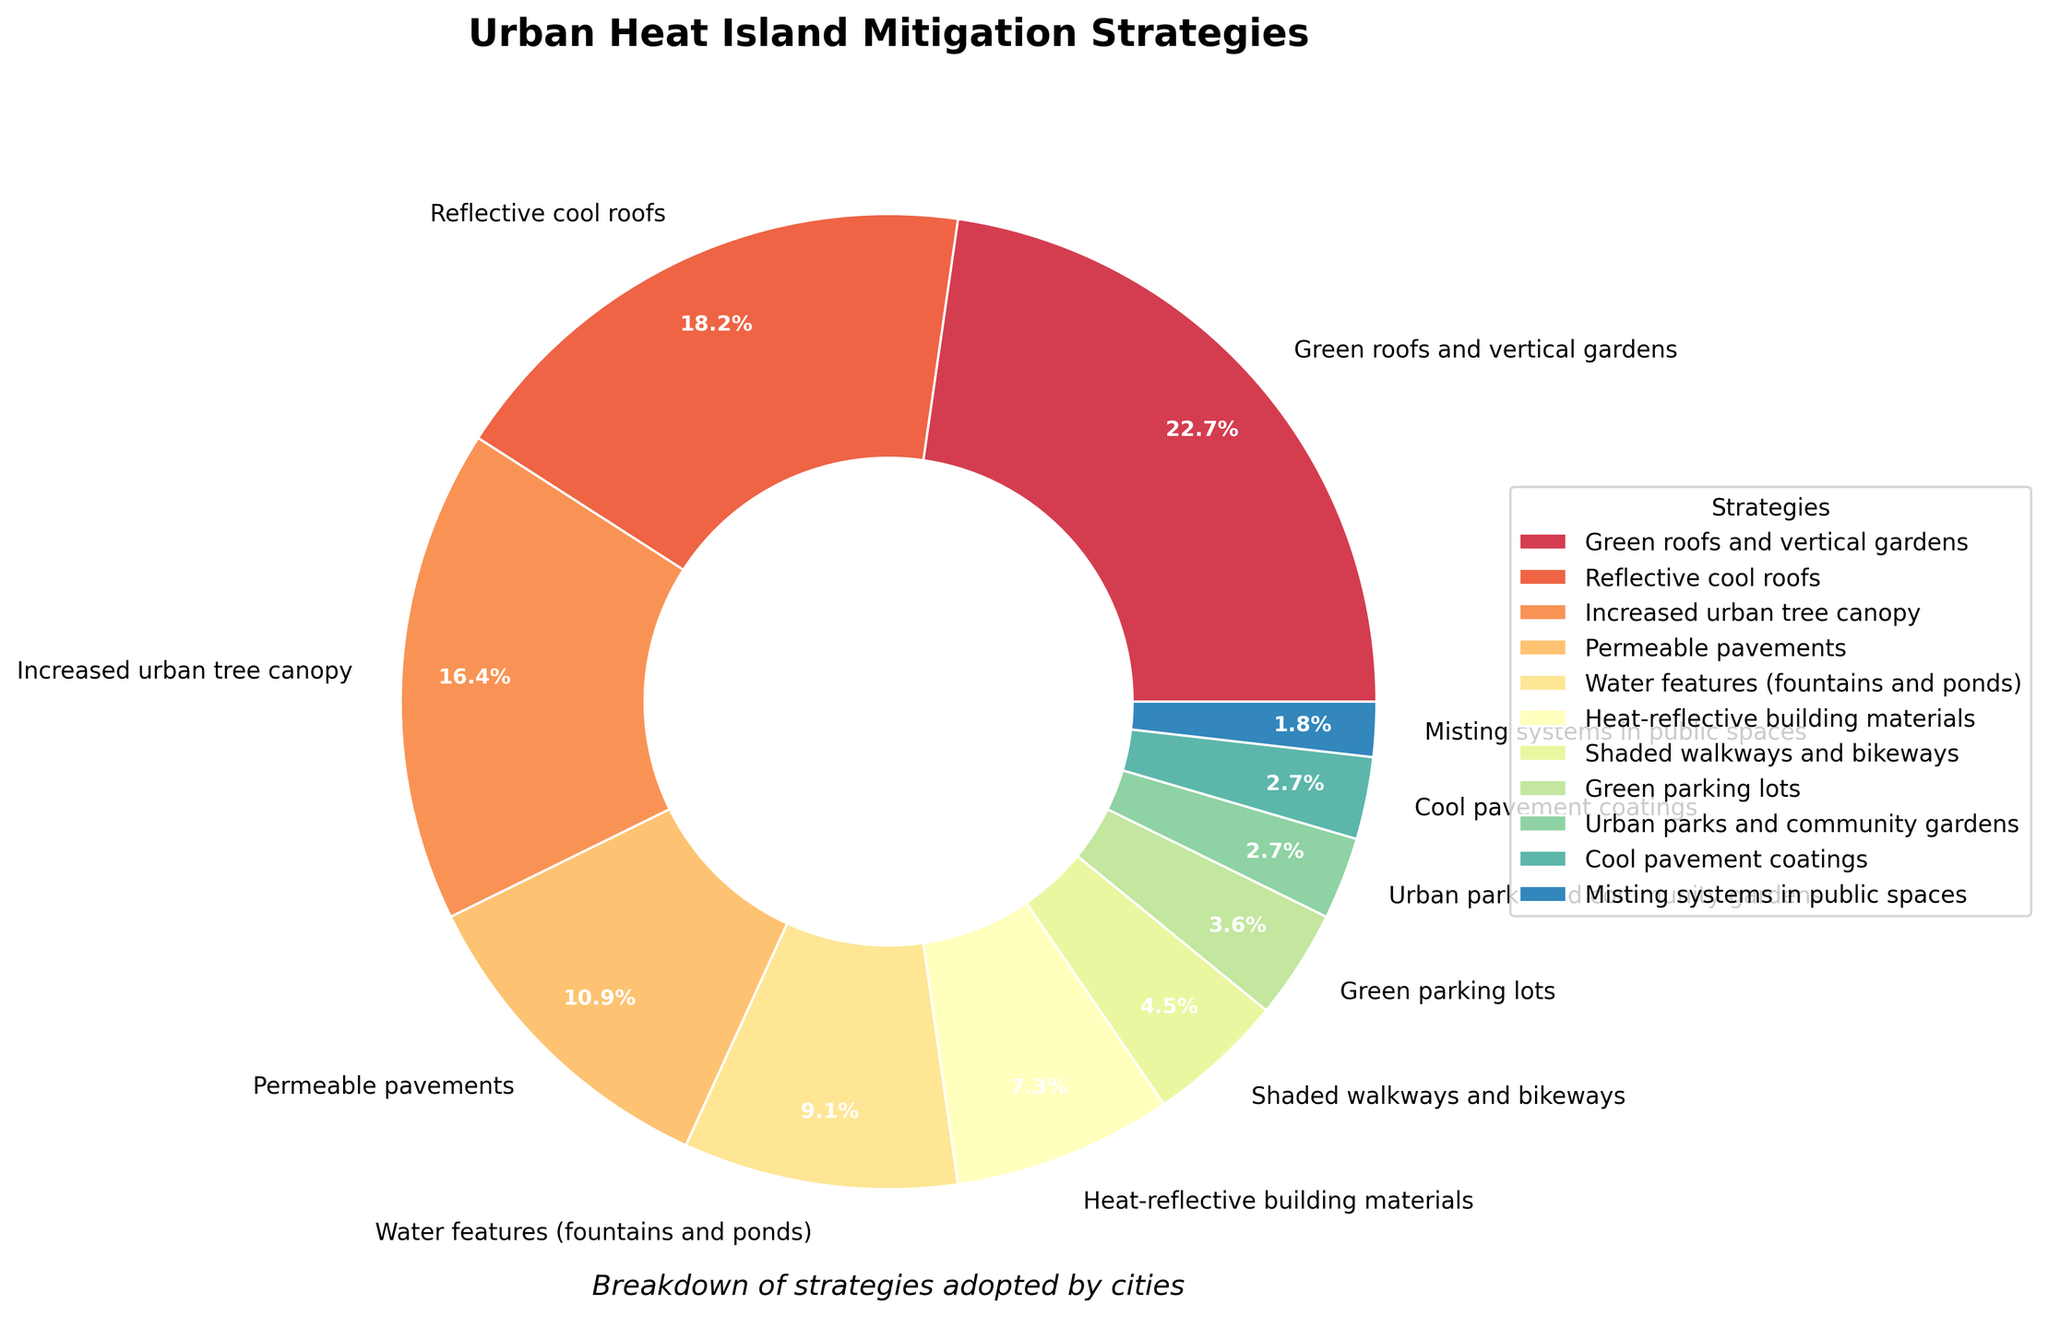What is the strategy with the highest percentage adoption? Identify the largest segment in the pie chart. The segment labeled "Green roofs and vertical gardens" has the highest percentage of 25%.
Answer: Green roofs and vertical gardens How much more popular is "Reflective cool roofs" compared to "Heat-reflective building materials"? Subtract the percentage of "Heat-reflective building materials" (8%) from "Reflective cool roofs" (20%). 20% - 8% = 12%
Answer: 12% What is the combined percentage of "Permeable pavements" and "Water features (fountains and ponds)"? Add the percentages of "Permeable pavements" (12%) and "Water features (fountains and ponds)" (10%). 12% + 10% = 22%
Answer: 22% Which strategies have a 3% adoption rate? Look for segments in the pie chart labeled with 3%. The segments for "Urban parks and community gardens" and "Cool pavement coatings" both have a 3% adoption rate.
Answer: Urban parks and community gardens, Cool pavement coatings Among the displayed strategies, which ones are adopted less frequently than "Increased urban tree canopy"? Compare the percentage of "Increased urban tree canopy" (18%) with other strategies. The strategies adopted less frequently are "Permeable pavements" (12%), "Water features (fountains and ponds)" (10%), "Heat-reflective building materials" (8%), "Shaded walkways and bikeways" (5%), "Green parking lots" (4%), "Urban parks and community gardens" (3%), "Cool pavement coatings" (3%), and "Misting systems in public spaces" (2%).
Answer: Permeable pavements, Water features (fountains and ponds), Heat-reflective building materials, Shaded walkways and bikeways, Green parking lots, Urban parks and community gardens, Cool pavement coatings, Misting systems in public spaces What is the total percentage of the three least adopted strategies combined? Add the percentages of the three least adopted strategies: "Green parking lots" (4%), "Urban parks and community gardens" (3%), and "Misting systems in public spaces" (2%). 4% + 3% + 2% = 9%
Answer: 9% What percentage of strategies adopted involve vegetation, such as trees and gardens? Add the percentages of strategies involving vegetation: "Green roofs and vertical gardens" (25%), "Increased urban tree canopy" (18%), and "Urban parks and community gardens" (3%). 25% + 18% + 3% = 46%
Answer: 46% Is "Shaded walkways and bikeways" adoption rate greater than "Misting systems in public spaces"? Compare the percentages of "Shaded walkways and bikeways" (5%) and "Misting systems in public spaces" (2%). Since 5% > 2%, the adoption rate of "Shaded walkways and bikeways" is indeed greater.
Answer: Yes 